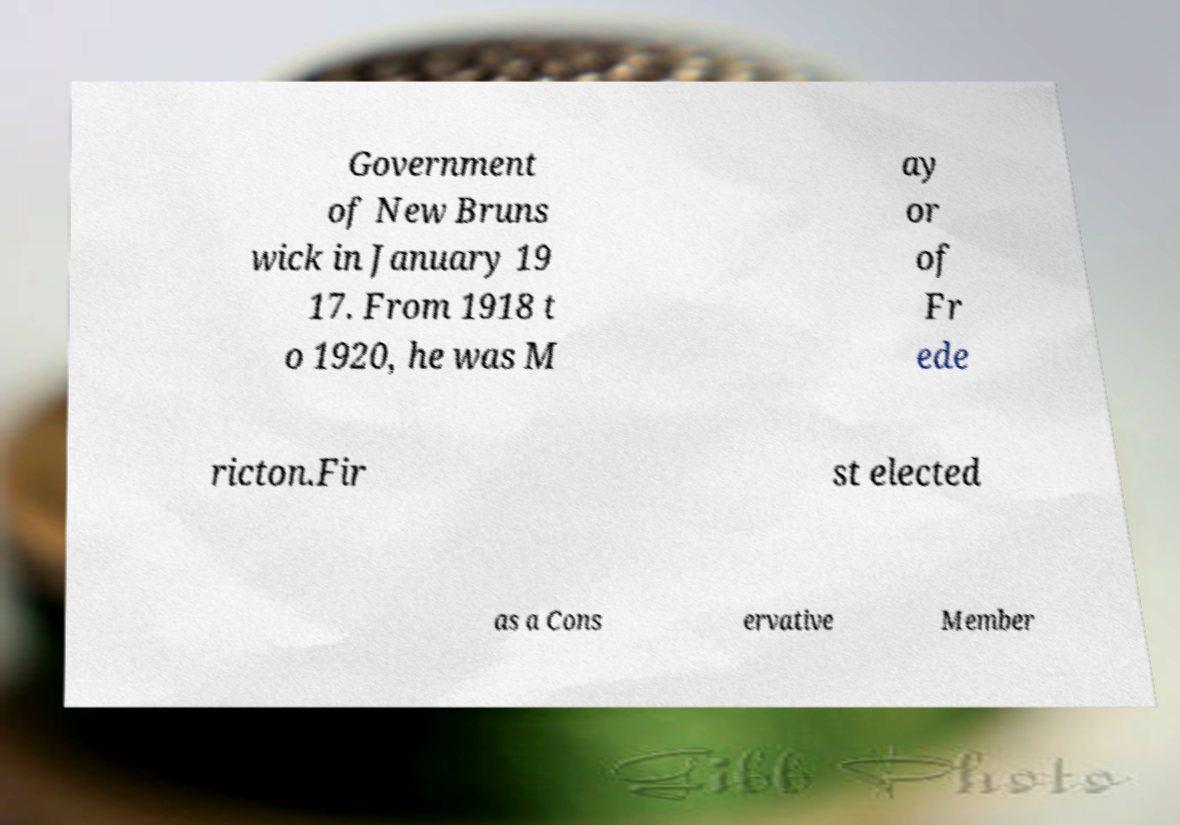Can you accurately transcribe the text from the provided image for me? Government of New Bruns wick in January 19 17. From 1918 t o 1920, he was M ay or of Fr ede ricton.Fir st elected as a Cons ervative Member 